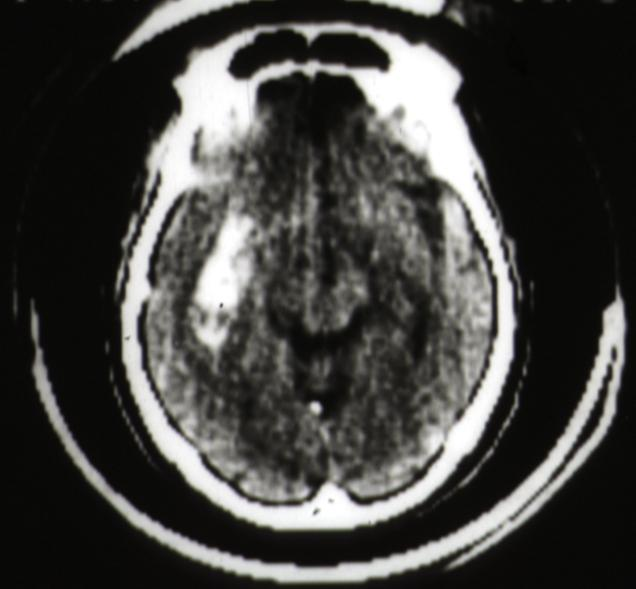does cat scan putamen hemorrhage?
Answer the question using a single word or phrase. Yes 